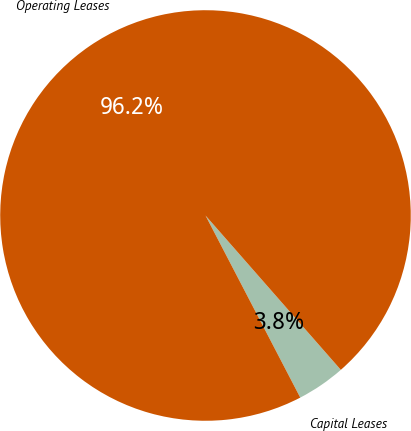<chart> <loc_0><loc_0><loc_500><loc_500><pie_chart><fcel>Capital Leases<fcel>Operating Leases<nl><fcel>3.82%<fcel>96.18%<nl></chart> 